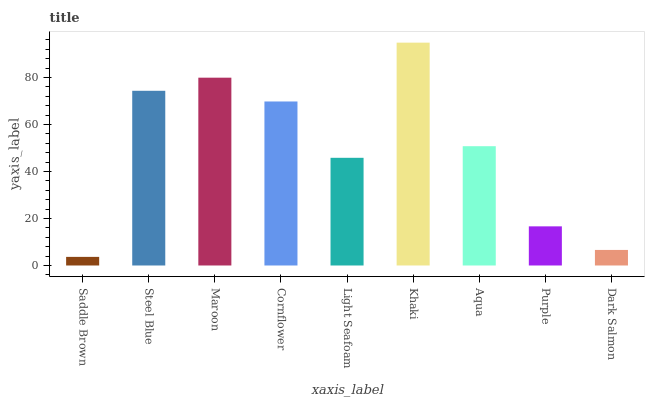Is Saddle Brown the minimum?
Answer yes or no. Yes. Is Khaki the maximum?
Answer yes or no. Yes. Is Steel Blue the minimum?
Answer yes or no. No. Is Steel Blue the maximum?
Answer yes or no. No. Is Steel Blue greater than Saddle Brown?
Answer yes or no. Yes. Is Saddle Brown less than Steel Blue?
Answer yes or no. Yes. Is Saddle Brown greater than Steel Blue?
Answer yes or no. No. Is Steel Blue less than Saddle Brown?
Answer yes or no. No. Is Aqua the high median?
Answer yes or no. Yes. Is Aqua the low median?
Answer yes or no. Yes. Is Maroon the high median?
Answer yes or no. No. Is Maroon the low median?
Answer yes or no. No. 